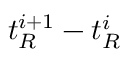Convert formula to latex. <formula><loc_0><loc_0><loc_500><loc_500>t _ { R } ^ { i + 1 } - t _ { R } ^ { i }</formula> 